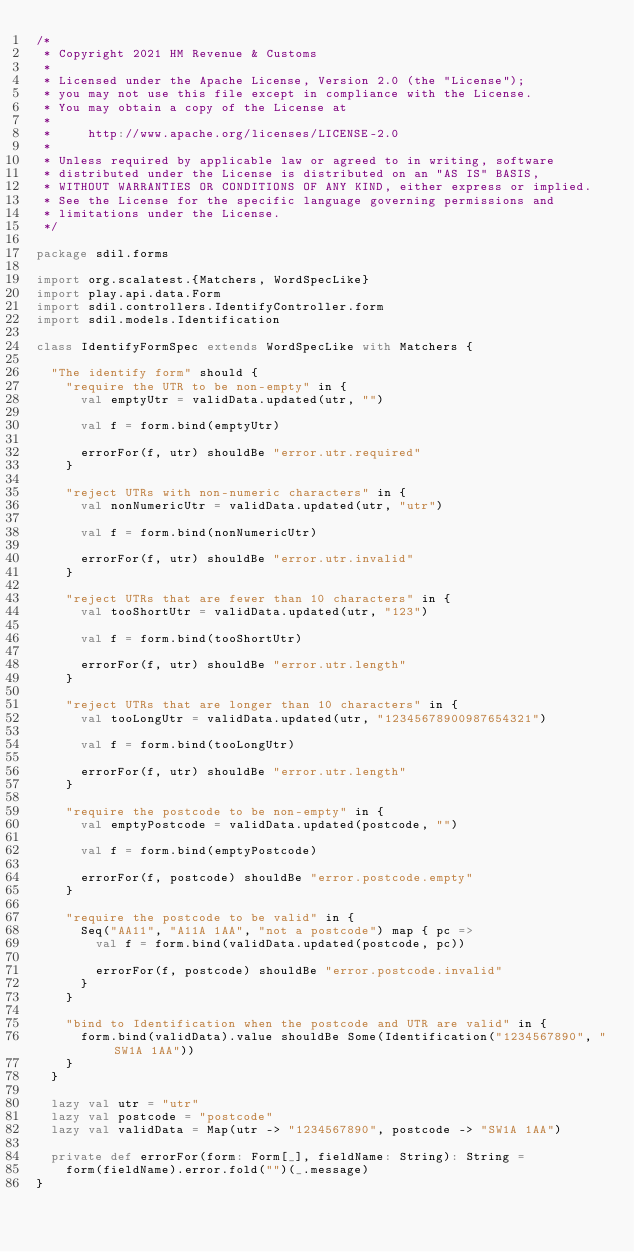<code> <loc_0><loc_0><loc_500><loc_500><_Scala_>/*
 * Copyright 2021 HM Revenue & Customs
 *
 * Licensed under the Apache License, Version 2.0 (the "License");
 * you may not use this file except in compliance with the License.
 * You may obtain a copy of the License at
 *
 *     http://www.apache.org/licenses/LICENSE-2.0
 *
 * Unless required by applicable law or agreed to in writing, software
 * distributed under the License is distributed on an "AS IS" BASIS,
 * WITHOUT WARRANTIES OR CONDITIONS OF ANY KIND, either express or implied.
 * See the License for the specific language governing permissions and
 * limitations under the License.
 */

package sdil.forms

import org.scalatest.{Matchers, WordSpecLike}
import play.api.data.Form
import sdil.controllers.IdentifyController.form
import sdil.models.Identification

class IdentifyFormSpec extends WordSpecLike with Matchers {

  "The identify form" should {
    "require the UTR to be non-empty" in {
      val emptyUtr = validData.updated(utr, "")

      val f = form.bind(emptyUtr)

      errorFor(f, utr) shouldBe "error.utr.required"
    }

    "reject UTRs with non-numeric characters" in {
      val nonNumericUtr = validData.updated(utr, "utr")

      val f = form.bind(nonNumericUtr)

      errorFor(f, utr) shouldBe "error.utr.invalid"
    }

    "reject UTRs that are fewer than 10 characters" in {
      val tooShortUtr = validData.updated(utr, "123")

      val f = form.bind(tooShortUtr)

      errorFor(f, utr) shouldBe "error.utr.length"
    }

    "reject UTRs that are longer than 10 characters" in {
      val tooLongUtr = validData.updated(utr, "12345678900987654321")

      val f = form.bind(tooLongUtr)

      errorFor(f, utr) shouldBe "error.utr.length"
    }

    "require the postcode to be non-empty" in {
      val emptyPostcode = validData.updated(postcode, "")

      val f = form.bind(emptyPostcode)

      errorFor(f, postcode) shouldBe "error.postcode.empty"
    }

    "require the postcode to be valid" in {
      Seq("AA11", "A11A 1AA", "not a postcode") map { pc =>
        val f = form.bind(validData.updated(postcode, pc))

        errorFor(f, postcode) shouldBe "error.postcode.invalid"
      }
    }

    "bind to Identification when the postcode and UTR are valid" in {
      form.bind(validData).value shouldBe Some(Identification("1234567890", "SW1A 1AA"))
    }
  }

  lazy val utr = "utr"
  lazy val postcode = "postcode"
  lazy val validData = Map(utr -> "1234567890", postcode -> "SW1A 1AA")

  private def errorFor(form: Form[_], fieldName: String): String =
    form(fieldName).error.fold("")(_.message)
}
</code> 